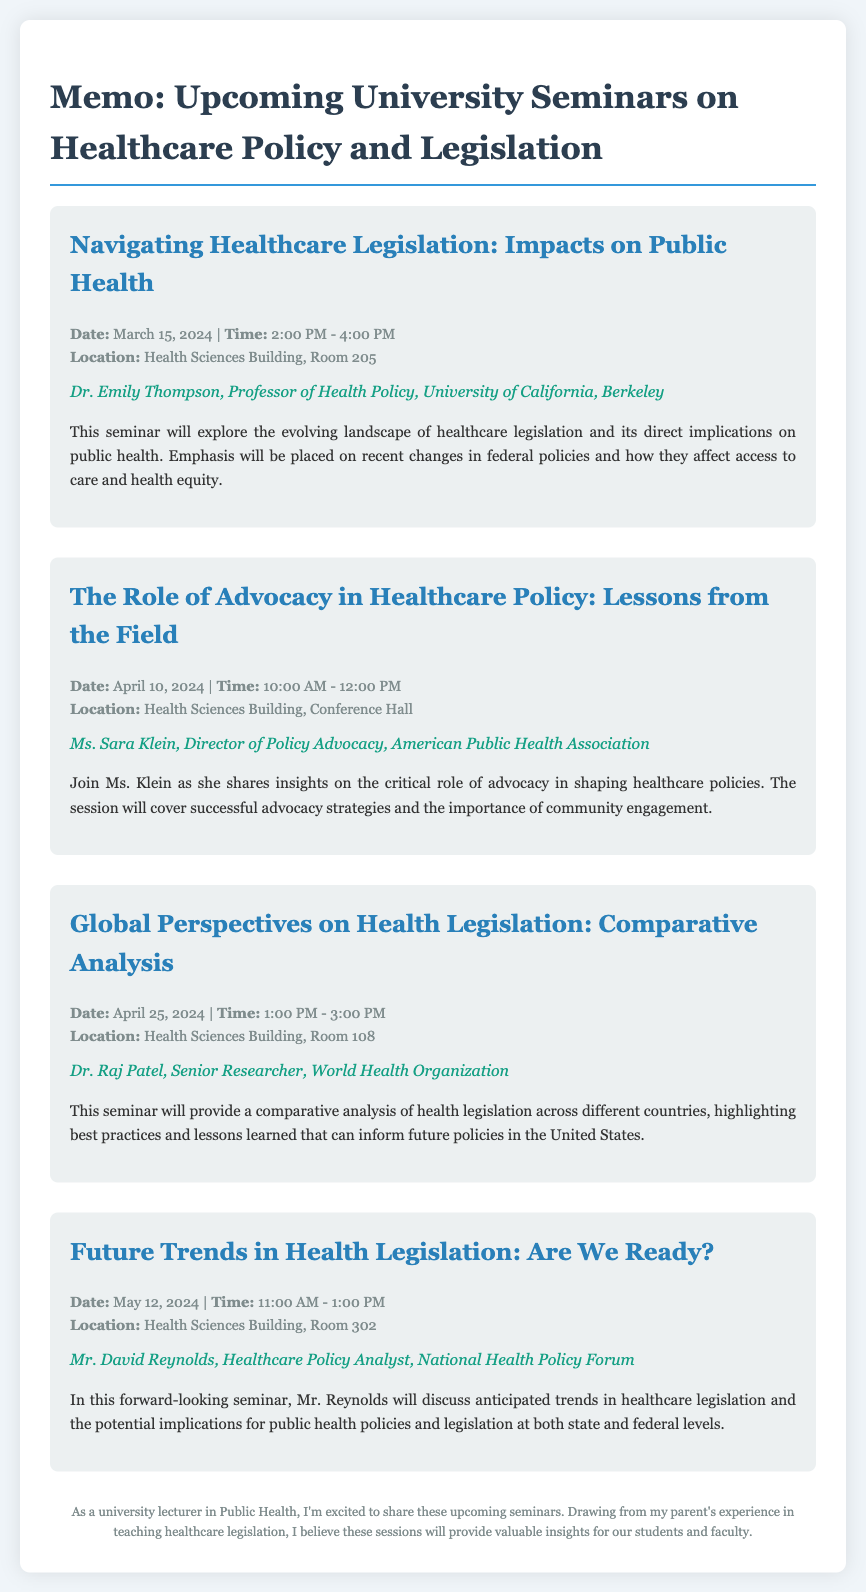What is the title of the first seminar? The title can be found in the first seminar section of the memo, which is "Navigating Healthcare Legislation: Impacts on Public Health."
Answer: Navigating Healthcare Legislation: Impacts on Public Health Who is the speaker for the second seminar? The speaker for the second seminar is detailed in that seminar section and is Ms. Sara Klein.
Answer: Ms. Sara Klein What date is the seminar on global perspectives scheduled? The date for the seminar on global perspectives is mentioned in its details, which is April 25, 2024.
Answer: April 25, 2024 What is the time for the seminar on future trends? The time for the seminar on future trends is given in its details, which is from 11:00 AM to 1:00 PM.
Answer: 11:00 AM - 1:00 PM What is the location of the second seminar? The location for the second seminar is specified in the details section, which is Health Sciences Building, Conference Hall.
Answer: Health Sciences Building, Conference Hall What is the main focus of Dr. Emily Thompson's seminar? The focus is described in the summary of her seminar, which states it will explore the evolving landscape of healthcare legislation and its implications on public health.
Answer: Evolving landscape of healthcare legislation and its implications on public health How many seminars are detailed in the memo? The total number of seminars is counted by reviewing the seminar sections listed, which totals four.
Answer: Four What organization is Ms. Sara Klein associated with? The organization is stated in the speaker details, which is the American Public Health Association.
Answer: American Public Health Association 